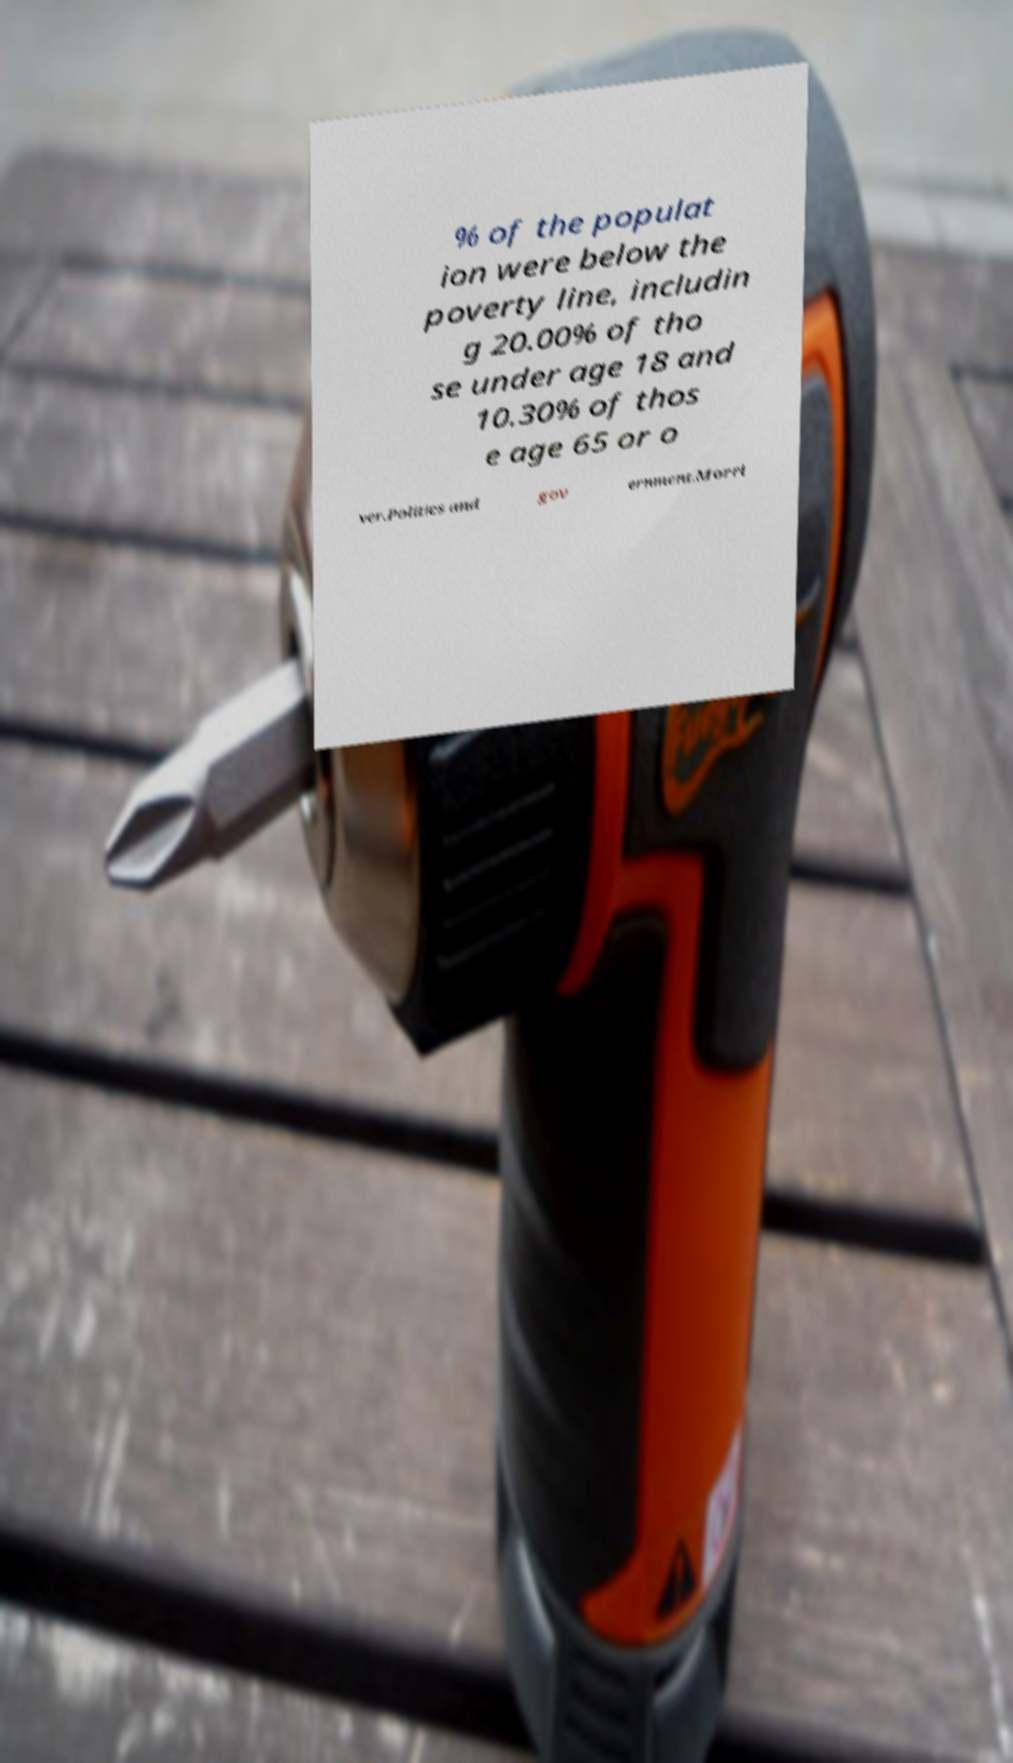Could you extract and type out the text from this image? % of the populat ion were below the poverty line, includin g 20.00% of tho se under age 18 and 10.30% of thos e age 65 or o ver.Politics and gov ernment.Morri 